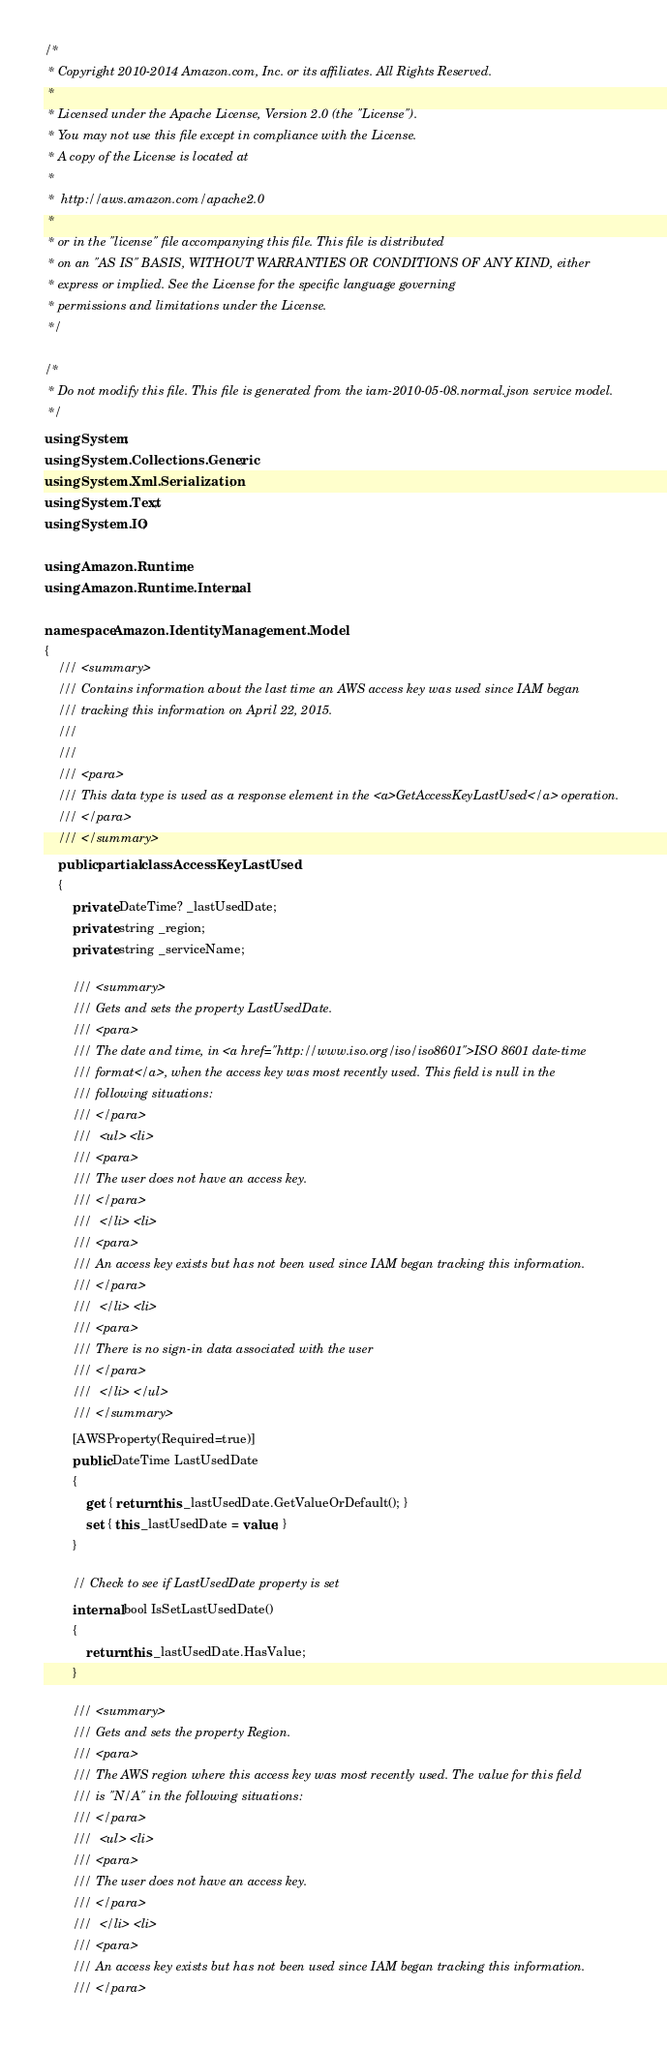Convert code to text. <code><loc_0><loc_0><loc_500><loc_500><_C#_>/*
 * Copyright 2010-2014 Amazon.com, Inc. or its affiliates. All Rights Reserved.
 * 
 * Licensed under the Apache License, Version 2.0 (the "License").
 * You may not use this file except in compliance with the License.
 * A copy of the License is located at
 * 
 *  http://aws.amazon.com/apache2.0
 * 
 * or in the "license" file accompanying this file. This file is distributed
 * on an "AS IS" BASIS, WITHOUT WARRANTIES OR CONDITIONS OF ANY KIND, either
 * express or implied. See the License for the specific language governing
 * permissions and limitations under the License.
 */

/*
 * Do not modify this file. This file is generated from the iam-2010-05-08.normal.json service model.
 */
using System;
using System.Collections.Generic;
using System.Xml.Serialization;
using System.Text;
using System.IO;

using Amazon.Runtime;
using Amazon.Runtime.Internal;

namespace Amazon.IdentityManagement.Model
{
    /// <summary>
    /// Contains information about the last time an AWS access key was used since IAM began
    /// tracking this information on April 22, 2015.
    /// 
    ///  
    /// <para>
    /// This data type is used as a response element in the <a>GetAccessKeyLastUsed</a> operation.
    /// </para>
    /// </summary>
    public partial class AccessKeyLastUsed
    {
        private DateTime? _lastUsedDate;
        private string _region;
        private string _serviceName;

        /// <summary>
        /// Gets and sets the property LastUsedDate. 
        /// <para>
        /// The date and time, in <a href="http://www.iso.org/iso/iso8601">ISO 8601 date-time
        /// format</a>, when the access key was most recently used. This field is null in the
        /// following situations:
        /// </para>
        ///  <ul> <li> 
        /// <para>
        /// The user does not have an access key.
        /// </para>
        ///  </li> <li> 
        /// <para>
        /// An access key exists but has not been used since IAM began tracking this information.
        /// </para>
        ///  </li> <li> 
        /// <para>
        /// There is no sign-in data associated with the user
        /// </para>
        ///  </li> </ul>
        /// </summary>
        [AWSProperty(Required=true)]
        public DateTime LastUsedDate
        {
            get { return this._lastUsedDate.GetValueOrDefault(); }
            set { this._lastUsedDate = value; }
        }

        // Check to see if LastUsedDate property is set
        internal bool IsSetLastUsedDate()
        {
            return this._lastUsedDate.HasValue; 
        }

        /// <summary>
        /// Gets and sets the property Region. 
        /// <para>
        /// The AWS region where this access key was most recently used. The value for this field
        /// is "N/A" in the following situations:
        /// </para>
        ///  <ul> <li> 
        /// <para>
        /// The user does not have an access key.
        /// </para>
        ///  </li> <li> 
        /// <para>
        /// An access key exists but has not been used since IAM began tracking this information.
        /// </para></code> 